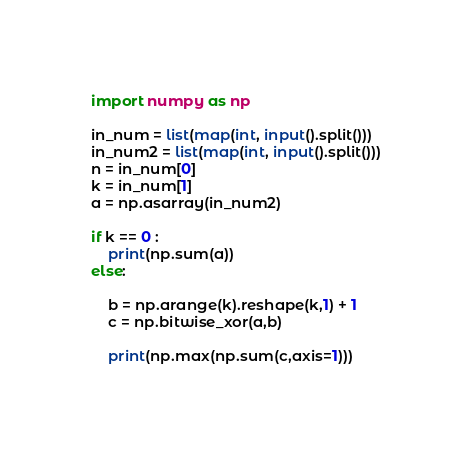<code> <loc_0><loc_0><loc_500><loc_500><_Python_>import numpy as np

in_num = list(map(int, input().split()))
in_num2 = list(map(int, input().split()))
n = in_num[0]
k = in_num[1]
a = np.asarray(in_num2)

if k == 0 :
    print(np.sum(a))
else:

    b = np.arange(k).reshape(k,1) + 1
    c = np.bitwise_xor(a,b)

    print(np.max(np.sum(c,axis=1)))</code> 